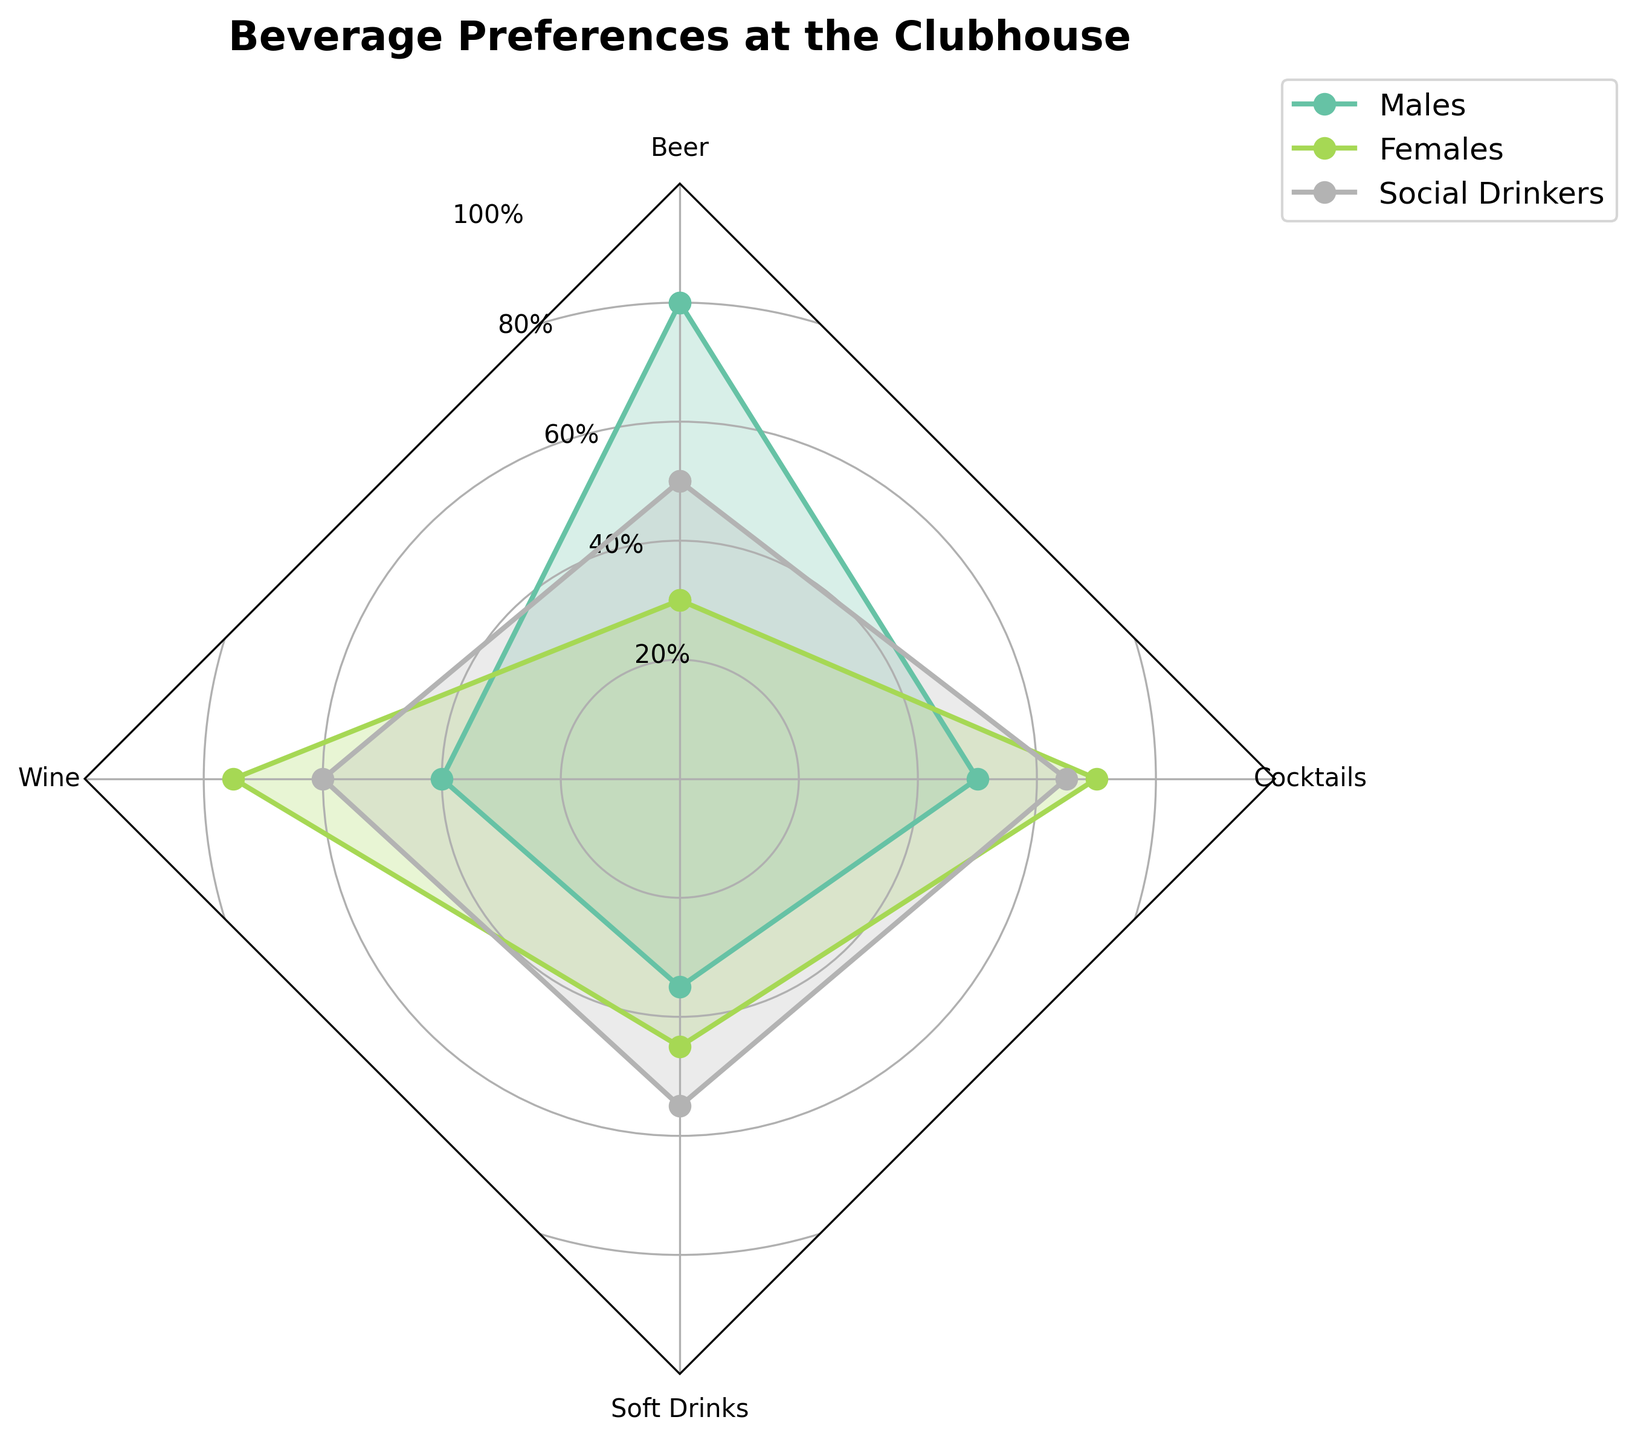What is the title of the radar chart? The title of the radar chart is displayed prominently at the top of the figure. It helps you understand what the chart is about without a deep dive into the data.
Answer: Beverage Preferences at the Clubhouse Which group has the highest preference rate for Wine? By looking at the Wine axis on the radar chart and observing where each group plots their highest point, you can see which group reaches the highest. For the highest preference rate, look for the highest plotted point amongst all groups.
Answer: Females What is the preference rate for Beer among Social Drinkers? Locate the "Beer" axis and follow the corresponding plot line for the Social Drinkers group to see the preference rate marked there.
Answer: 50% Among Males and Females, who has a higher preference rate for Cocktails? Compare the plotted points on the Cocktails axis for both Males and Females. Notice who has the plotted point higher on the axis.
Answer: Females What is the average preference rate for Soft Drinks across all groups? Determine the preference rates for Soft Drinks for all groups: Males (35), Females (45), Social Drinkers (55). Then, calculate the average ((35 + 45 + 55) / 3).
Answer: 45 Which group has the most balanced preference rates across all beverage types? The most balanced preference rates are indicated by the group whose plot line is closest to being circular. By visually inspecting the radar chart, check which group has preference rates that do not vary widely.
Answer: Social Drinkers What is the total preference rate for Wine and Beer among Females? Add the preference rates for Wine (75) and Beer (30) for the Females group.
Answer: 105 Out of all the beverage types, for which ones do Social Drinkers have a higher preference rate than Males? Compare the plotted points of Social Drinkers and Males for each beverage type:
- Beer: Social Drinkers 50 < Males 80
- Wine: Social Drinkers 60 > Males 40 
- Soft Drinks: Social Drinkers 55 > Males 35 
- Cocktails: Social Drinkers 65 > Males 50
Preferences are higher for Wine, Soft Drinks, and Cocktails.
Answer: Wine, Soft Drinks, Cocktails Which beverage type has the highest overall preference rate among all groups? Identify the highest plotted point across all groups and beverage types on the radar chart.
Answer: Beer (Males, 80%) 